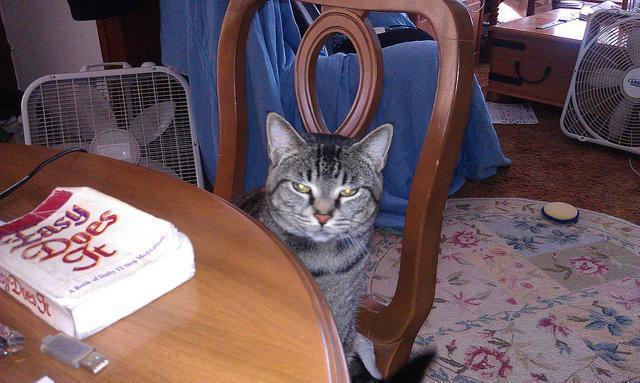The cat is sitting at a table with what featured on top of it?
Indicate the correct choice and explain in the format: 'Answer: answer
Rationale: rationale.'
Options: Plate, fan, knife, book. Answer: book.
Rationale: The cat is by the book. 